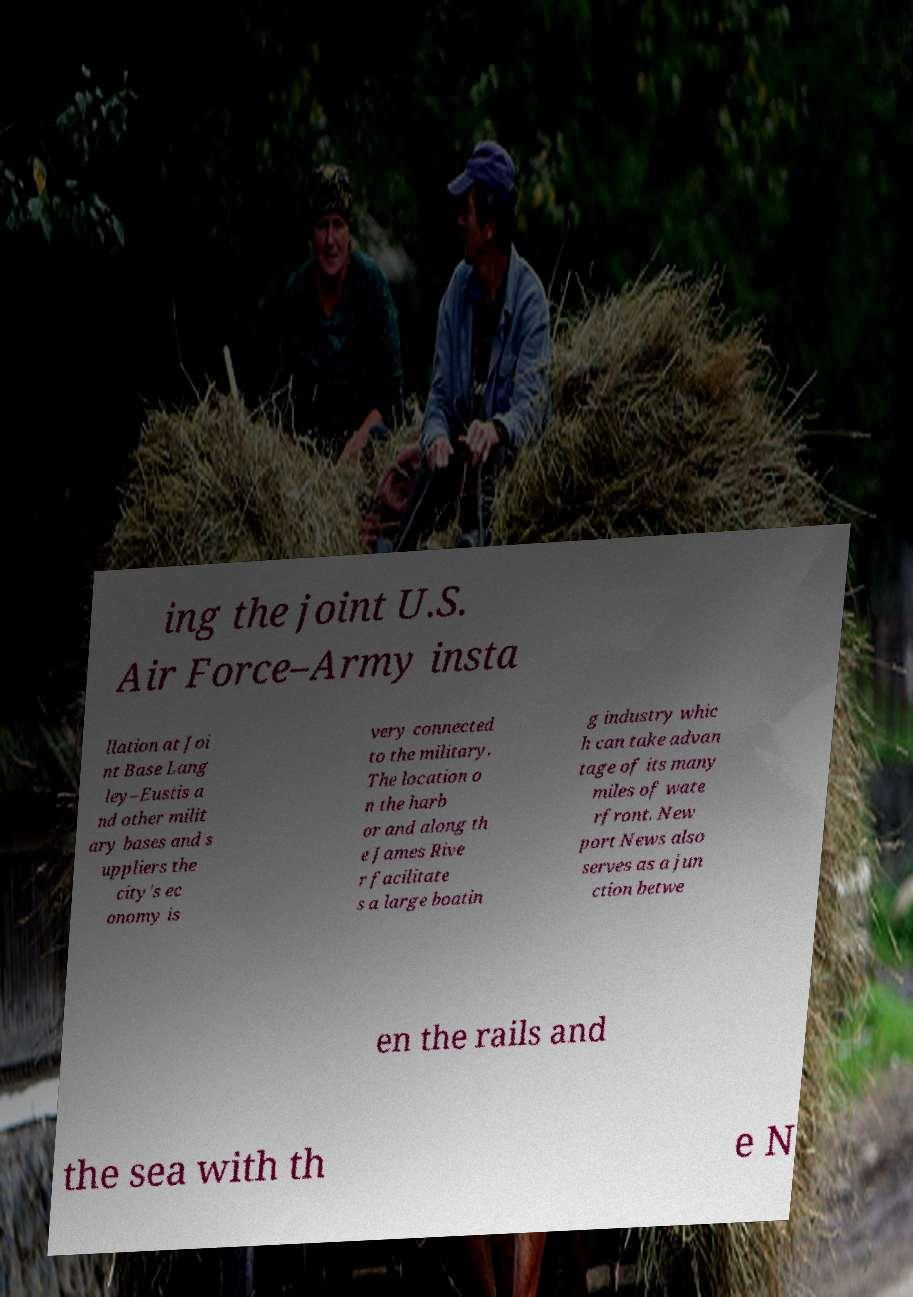Can you accurately transcribe the text from the provided image for me? ing the joint U.S. Air Force–Army insta llation at Joi nt Base Lang ley–Eustis a nd other milit ary bases and s uppliers the city's ec onomy is very connected to the military. The location o n the harb or and along th e James Rive r facilitate s a large boatin g industry whic h can take advan tage of its many miles of wate rfront. New port News also serves as a jun ction betwe en the rails and the sea with th e N 